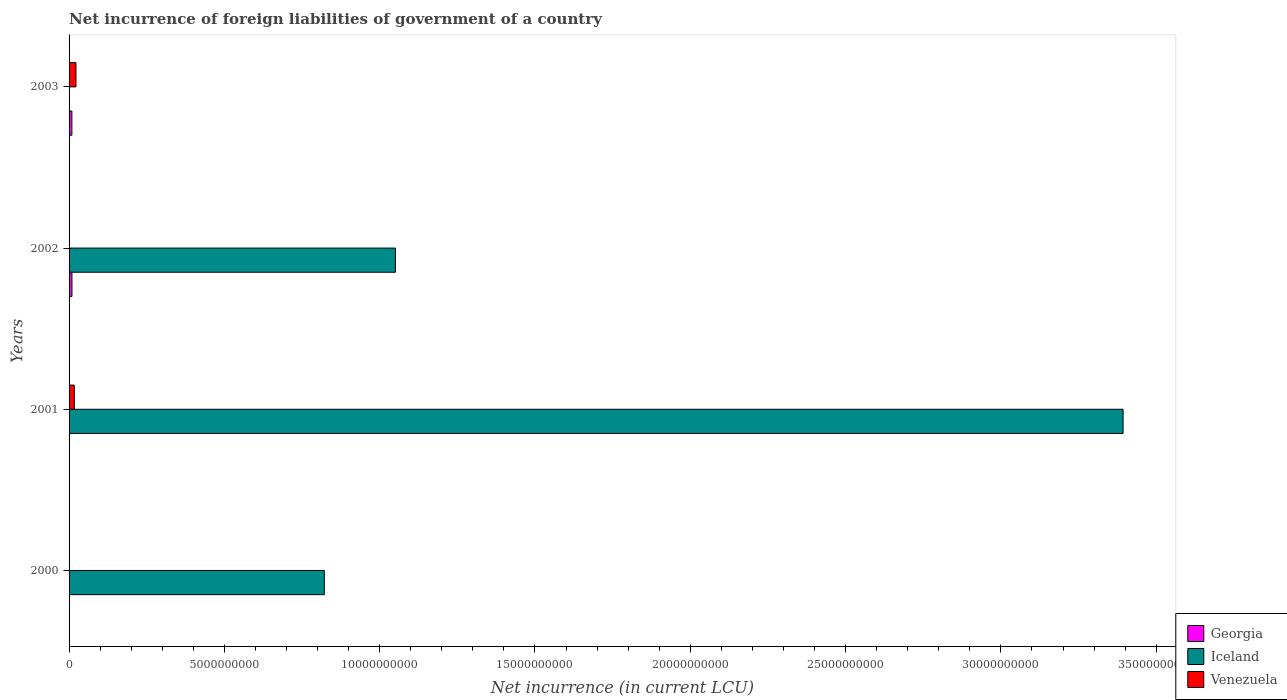Are the number of bars per tick equal to the number of legend labels?
Keep it short and to the point. No. How many bars are there on the 4th tick from the top?
Offer a very short reply. 1. What is the label of the 1st group of bars from the top?
Make the answer very short. 2003. In how many cases, is the number of bars for a given year not equal to the number of legend labels?
Provide a succinct answer. 4. What is the net incurrence of foreign liabilities in Iceland in 2001?
Provide a succinct answer. 3.39e+1. Across all years, what is the maximum net incurrence of foreign liabilities in Iceland?
Your answer should be very brief. 3.39e+1. Across all years, what is the minimum net incurrence of foreign liabilities in Iceland?
Provide a succinct answer. 0. What is the total net incurrence of foreign liabilities in Georgia in the graph?
Give a very brief answer. 1.84e+08. What is the difference between the net incurrence of foreign liabilities in Georgia in 2002 and that in 2003?
Offer a very short reply. 2.20e+06. What is the difference between the net incurrence of foreign liabilities in Georgia in 2000 and the net incurrence of foreign liabilities in Venezuela in 2001?
Your answer should be very brief. -1.68e+08. What is the average net incurrence of foreign liabilities in Venezuela per year?
Ensure brevity in your answer.  9.73e+07. In the year 2003, what is the difference between the net incurrence of foreign liabilities in Venezuela and net incurrence of foreign liabilities in Georgia?
Offer a terse response. 1.31e+08. What is the ratio of the net incurrence of foreign liabilities in Venezuela in 2001 to that in 2003?
Provide a short and direct response. 0.76. Is the net incurrence of foreign liabilities in Georgia in 2002 less than that in 2003?
Make the answer very short. No. What is the difference between the highest and the second highest net incurrence of foreign liabilities in Iceland?
Your answer should be very brief. 2.34e+1. What is the difference between the highest and the lowest net incurrence of foreign liabilities in Georgia?
Make the answer very short. 9.29e+07. In how many years, is the net incurrence of foreign liabilities in Georgia greater than the average net incurrence of foreign liabilities in Georgia taken over all years?
Your answer should be compact. 2. How many bars are there?
Give a very brief answer. 7. Are all the bars in the graph horizontal?
Provide a short and direct response. Yes. What is the difference between two consecutive major ticks on the X-axis?
Ensure brevity in your answer.  5.00e+09. Are the values on the major ticks of X-axis written in scientific E-notation?
Your answer should be compact. No. Does the graph contain any zero values?
Ensure brevity in your answer.  Yes. Where does the legend appear in the graph?
Give a very brief answer. Bottom right. How many legend labels are there?
Provide a short and direct response. 3. How are the legend labels stacked?
Provide a succinct answer. Vertical. What is the title of the graph?
Provide a short and direct response. Net incurrence of foreign liabilities of government of a country. What is the label or title of the X-axis?
Your answer should be very brief. Net incurrence (in current LCU). What is the label or title of the Y-axis?
Make the answer very short. Years. What is the Net incurrence (in current LCU) in Georgia in 2000?
Your response must be concise. 0. What is the Net incurrence (in current LCU) in Iceland in 2000?
Make the answer very short. 8.22e+09. What is the Net incurrence (in current LCU) of Georgia in 2001?
Offer a very short reply. 0. What is the Net incurrence (in current LCU) of Iceland in 2001?
Make the answer very short. 3.39e+1. What is the Net incurrence (in current LCU) of Venezuela in 2001?
Your answer should be compact. 1.68e+08. What is the Net incurrence (in current LCU) of Georgia in 2002?
Your answer should be compact. 9.29e+07. What is the Net incurrence (in current LCU) of Iceland in 2002?
Offer a terse response. 1.05e+1. What is the Net incurrence (in current LCU) of Georgia in 2003?
Make the answer very short. 9.07e+07. What is the Net incurrence (in current LCU) in Venezuela in 2003?
Offer a very short reply. 2.22e+08. Across all years, what is the maximum Net incurrence (in current LCU) in Georgia?
Make the answer very short. 9.29e+07. Across all years, what is the maximum Net incurrence (in current LCU) in Iceland?
Provide a short and direct response. 3.39e+1. Across all years, what is the maximum Net incurrence (in current LCU) in Venezuela?
Your response must be concise. 2.22e+08. Across all years, what is the minimum Net incurrence (in current LCU) in Georgia?
Provide a short and direct response. 0. Across all years, what is the minimum Net incurrence (in current LCU) of Iceland?
Keep it short and to the point. 0. Across all years, what is the minimum Net incurrence (in current LCU) of Venezuela?
Ensure brevity in your answer.  0. What is the total Net incurrence (in current LCU) of Georgia in the graph?
Make the answer very short. 1.84e+08. What is the total Net incurrence (in current LCU) of Iceland in the graph?
Give a very brief answer. 5.27e+1. What is the total Net incurrence (in current LCU) in Venezuela in the graph?
Provide a short and direct response. 3.89e+08. What is the difference between the Net incurrence (in current LCU) in Iceland in 2000 and that in 2001?
Provide a succinct answer. -2.57e+1. What is the difference between the Net incurrence (in current LCU) in Iceland in 2000 and that in 2002?
Give a very brief answer. -2.29e+09. What is the difference between the Net incurrence (in current LCU) of Iceland in 2001 and that in 2002?
Your response must be concise. 2.34e+1. What is the difference between the Net incurrence (in current LCU) of Venezuela in 2001 and that in 2003?
Your answer should be very brief. -5.43e+07. What is the difference between the Net incurrence (in current LCU) of Georgia in 2002 and that in 2003?
Your answer should be very brief. 2.20e+06. What is the difference between the Net incurrence (in current LCU) of Iceland in 2000 and the Net incurrence (in current LCU) of Venezuela in 2001?
Keep it short and to the point. 8.05e+09. What is the difference between the Net incurrence (in current LCU) in Iceland in 2000 and the Net incurrence (in current LCU) in Venezuela in 2003?
Make the answer very short. 8.00e+09. What is the difference between the Net incurrence (in current LCU) of Iceland in 2001 and the Net incurrence (in current LCU) of Venezuela in 2003?
Your answer should be very brief. 3.37e+1. What is the difference between the Net incurrence (in current LCU) in Georgia in 2002 and the Net incurrence (in current LCU) in Venezuela in 2003?
Offer a very short reply. -1.29e+08. What is the difference between the Net incurrence (in current LCU) of Iceland in 2002 and the Net incurrence (in current LCU) of Venezuela in 2003?
Ensure brevity in your answer.  1.03e+1. What is the average Net incurrence (in current LCU) of Georgia per year?
Ensure brevity in your answer.  4.59e+07. What is the average Net incurrence (in current LCU) of Iceland per year?
Make the answer very short. 1.32e+1. What is the average Net incurrence (in current LCU) of Venezuela per year?
Provide a short and direct response. 9.73e+07. In the year 2001, what is the difference between the Net incurrence (in current LCU) of Iceland and Net incurrence (in current LCU) of Venezuela?
Give a very brief answer. 3.38e+1. In the year 2002, what is the difference between the Net incurrence (in current LCU) in Georgia and Net incurrence (in current LCU) in Iceland?
Your response must be concise. -1.04e+1. In the year 2003, what is the difference between the Net incurrence (in current LCU) in Georgia and Net incurrence (in current LCU) in Venezuela?
Your answer should be compact. -1.31e+08. What is the ratio of the Net incurrence (in current LCU) in Iceland in 2000 to that in 2001?
Offer a terse response. 0.24. What is the ratio of the Net incurrence (in current LCU) of Iceland in 2000 to that in 2002?
Your answer should be very brief. 0.78. What is the ratio of the Net incurrence (in current LCU) in Iceland in 2001 to that in 2002?
Provide a short and direct response. 3.23. What is the ratio of the Net incurrence (in current LCU) of Venezuela in 2001 to that in 2003?
Your answer should be very brief. 0.76. What is the ratio of the Net incurrence (in current LCU) of Georgia in 2002 to that in 2003?
Offer a terse response. 1.02. What is the difference between the highest and the second highest Net incurrence (in current LCU) in Iceland?
Your answer should be very brief. 2.34e+1. What is the difference between the highest and the lowest Net incurrence (in current LCU) in Georgia?
Make the answer very short. 9.29e+07. What is the difference between the highest and the lowest Net incurrence (in current LCU) of Iceland?
Offer a terse response. 3.39e+1. What is the difference between the highest and the lowest Net incurrence (in current LCU) in Venezuela?
Offer a terse response. 2.22e+08. 